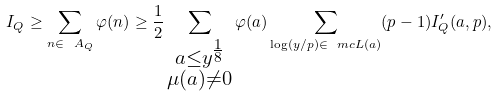<formula> <loc_0><loc_0><loc_500><loc_500>I _ { Q } \geq \sum _ { n \in \ A _ { Q } } \varphi ( n ) \geq \frac { 1 } { 2 } \sum _ { \substack { a \leq y ^ { \frac { 1 } { 8 } } \\ \mu ( a ) \ne 0 } } \varphi ( a ) \sum _ { \log ( y / p ) \in \ m c { L } ( a ) } ( p - 1 ) I _ { Q } ^ { \prime } ( a , p ) ,</formula> 